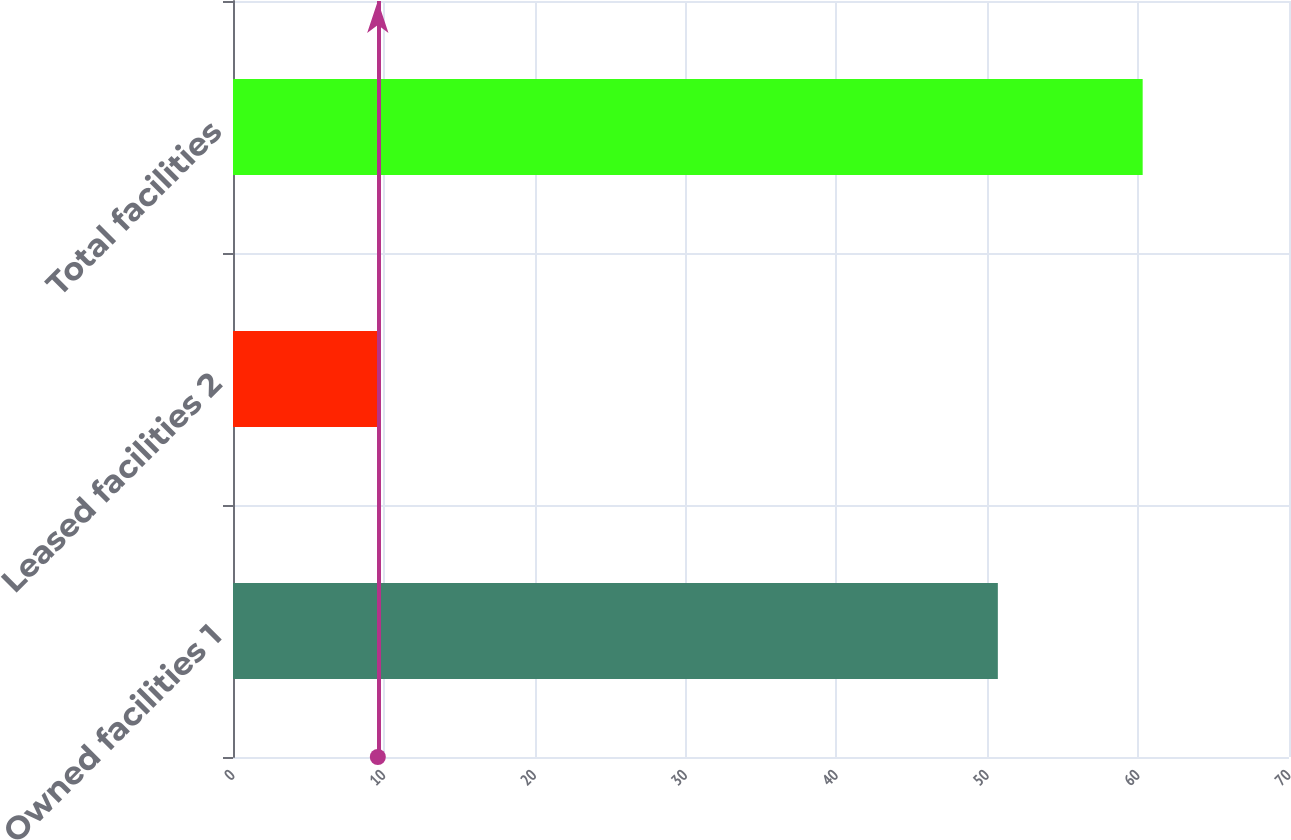Convert chart. <chart><loc_0><loc_0><loc_500><loc_500><bar_chart><fcel>Owned facilities 1<fcel>Leased facilities 2<fcel>Total facilities<nl><fcel>50.7<fcel>9.6<fcel>60.3<nl></chart> 